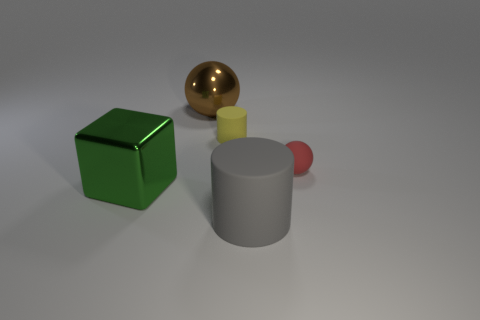Add 2 large things. How many objects exist? 7 Subtract 0 yellow cubes. How many objects are left? 5 Subtract all blocks. How many objects are left? 4 Subtract 1 cylinders. How many cylinders are left? 1 Subtract all gray balls. Subtract all cyan cubes. How many balls are left? 2 Subtract all yellow cylinders. How many cyan blocks are left? 0 Subtract all large red spheres. Subtract all red rubber things. How many objects are left? 4 Add 4 cylinders. How many cylinders are left? 6 Add 1 green metallic things. How many green metallic things exist? 2 Subtract all brown balls. How many balls are left? 1 